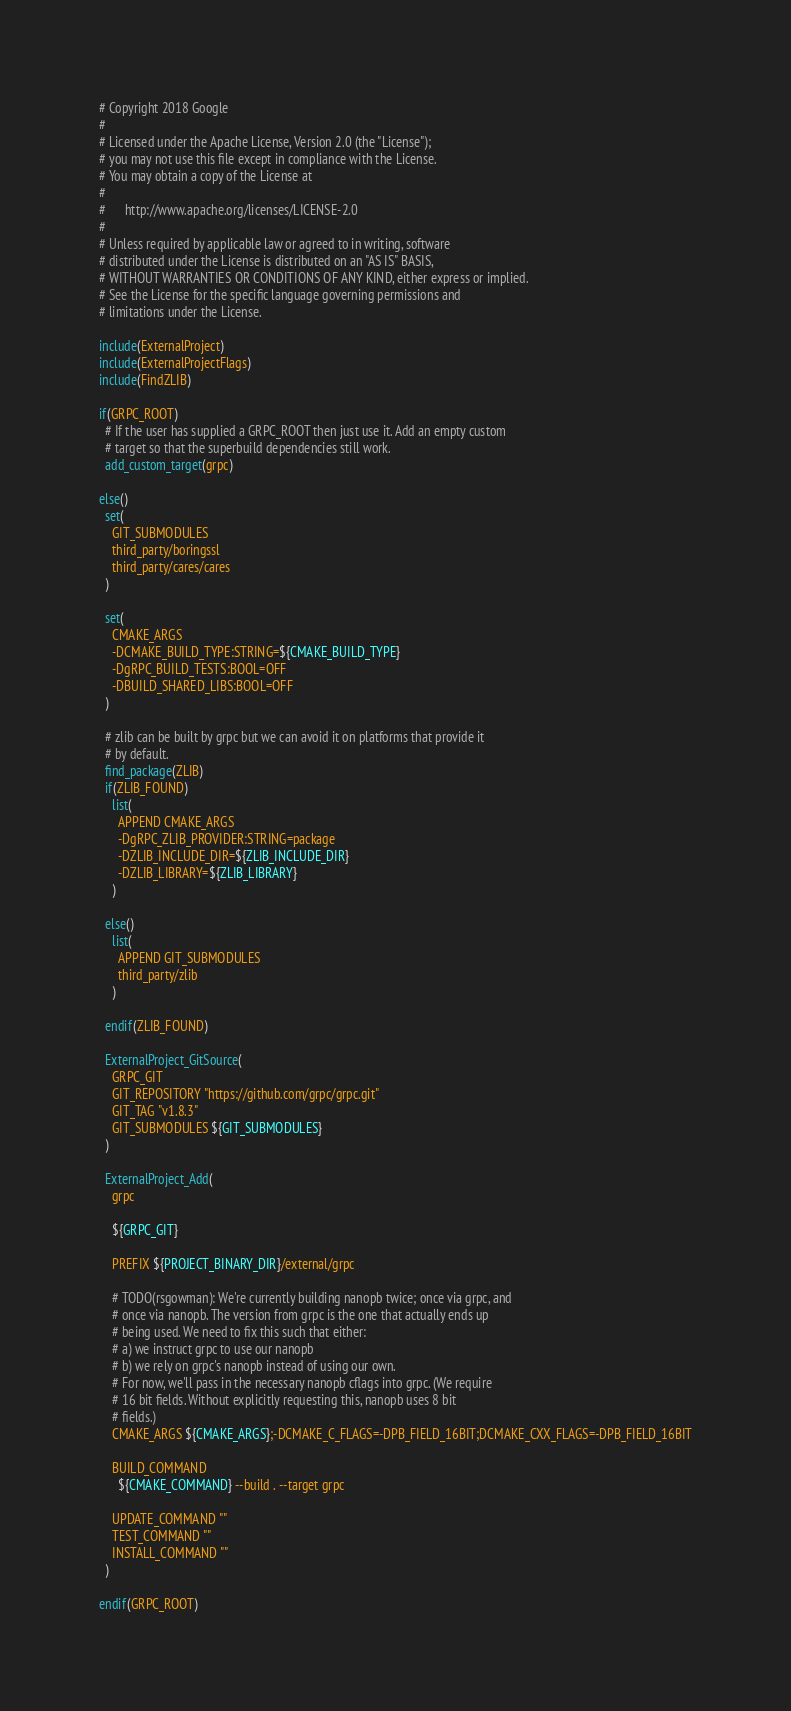<code> <loc_0><loc_0><loc_500><loc_500><_CMake_># Copyright 2018 Google
#
# Licensed under the Apache License, Version 2.0 (the "License");
# you may not use this file except in compliance with the License.
# You may obtain a copy of the License at
#
#      http://www.apache.org/licenses/LICENSE-2.0
#
# Unless required by applicable law or agreed to in writing, software
# distributed under the License is distributed on an "AS IS" BASIS,
# WITHOUT WARRANTIES OR CONDITIONS OF ANY KIND, either express or implied.
# See the License for the specific language governing permissions and
# limitations under the License.

include(ExternalProject)
include(ExternalProjectFlags)
include(FindZLIB)

if(GRPC_ROOT)
  # If the user has supplied a GRPC_ROOT then just use it. Add an empty custom
  # target so that the superbuild dependencies still work.
  add_custom_target(grpc)

else()
  set(
    GIT_SUBMODULES
    third_party/boringssl
    third_party/cares/cares
  )

  set(
    CMAKE_ARGS
    -DCMAKE_BUILD_TYPE:STRING=${CMAKE_BUILD_TYPE}
    -DgRPC_BUILD_TESTS:BOOL=OFF
    -DBUILD_SHARED_LIBS:BOOL=OFF
  )

  # zlib can be built by grpc but we can avoid it on platforms that provide it
  # by default.
  find_package(ZLIB)
  if(ZLIB_FOUND)
    list(
      APPEND CMAKE_ARGS
      -DgRPC_ZLIB_PROVIDER:STRING=package
      -DZLIB_INCLUDE_DIR=${ZLIB_INCLUDE_DIR}
      -DZLIB_LIBRARY=${ZLIB_LIBRARY}
    )

  else()
    list(
      APPEND GIT_SUBMODULES
      third_party/zlib
    )

  endif(ZLIB_FOUND)

  ExternalProject_GitSource(
    GRPC_GIT
    GIT_REPOSITORY "https://github.com/grpc/grpc.git"
    GIT_TAG "v1.8.3"
    GIT_SUBMODULES ${GIT_SUBMODULES}
  )

  ExternalProject_Add(
    grpc

    ${GRPC_GIT}

    PREFIX ${PROJECT_BINARY_DIR}/external/grpc

    # TODO(rsgowman): We're currently building nanopb twice; once via grpc, and
    # once via nanopb. The version from grpc is the one that actually ends up
    # being used. We need to fix this such that either:
    # a) we instruct grpc to use our nanopb
    # b) we rely on grpc's nanopb instead of using our own.
    # For now, we'll pass in the necessary nanopb cflags into grpc. (We require
    # 16 bit fields. Without explicitly requesting this, nanopb uses 8 bit
    # fields.)
    CMAKE_ARGS ${CMAKE_ARGS};-DCMAKE_C_FLAGS=-DPB_FIELD_16BIT;DCMAKE_CXX_FLAGS=-DPB_FIELD_16BIT

    BUILD_COMMAND
      ${CMAKE_COMMAND} --build . --target grpc

    UPDATE_COMMAND ""
    TEST_COMMAND ""
    INSTALL_COMMAND ""
  )

endif(GRPC_ROOT)

</code> 